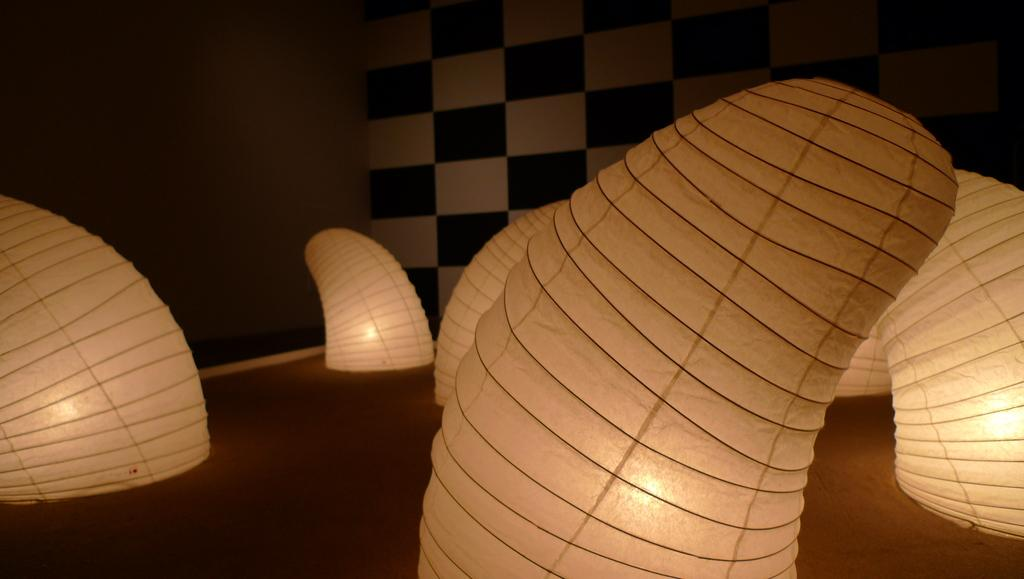What type of decorations can be seen in the image? There are paper lanterns in the image. Where are the paper lanterns located? The paper lanterns are present over a place. What type of thrill can be experienced by the tomatoes in the image? There are no tomatoes present in the image, so it is not possible to determine any thrill experienced by them. 